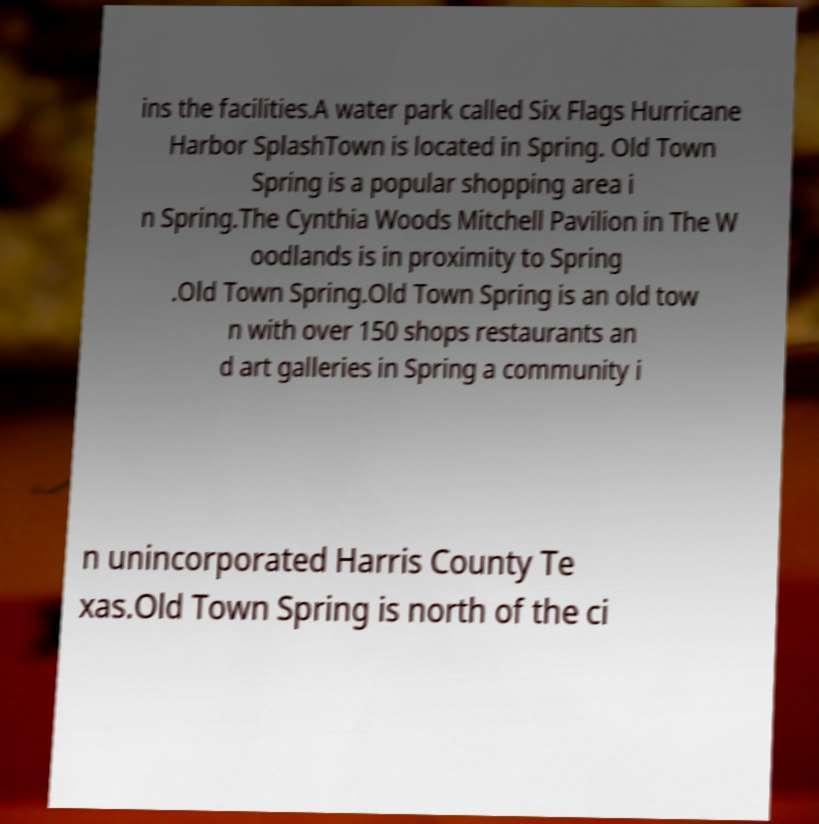There's text embedded in this image that I need extracted. Can you transcribe it verbatim? ins the facilities.A water park called Six Flags Hurricane Harbor SplashTown is located in Spring. Old Town Spring is a popular shopping area i n Spring.The Cynthia Woods Mitchell Pavilion in The W oodlands is in proximity to Spring .Old Town Spring.Old Town Spring is an old tow n with over 150 shops restaurants an d art galleries in Spring a community i n unincorporated Harris County Te xas.Old Town Spring is north of the ci 